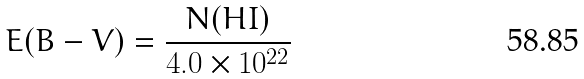<formula> <loc_0><loc_0><loc_500><loc_500>E ( B - V ) = \frac { N ( H I ) } { 4 . 0 \times 1 0 ^ { 2 2 } }</formula> 